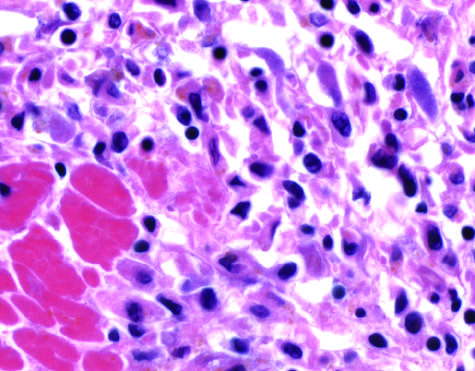when do the photomicrographs show an inflammatory reaction in the myocardium?
Answer the question using a single word or phrase. After ischemic necrosis infarction 